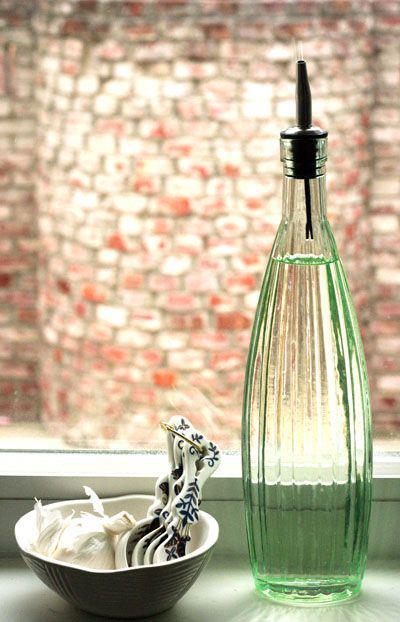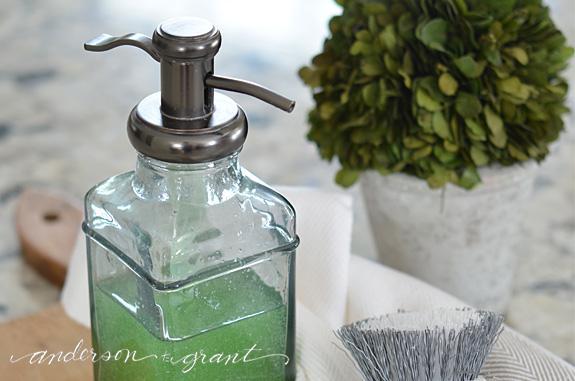The first image is the image on the left, the second image is the image on the right. Assess this claim about the two images: "A lone dispenser has some green soap in it.". Correct or not? Answer yes or no. Yes. 